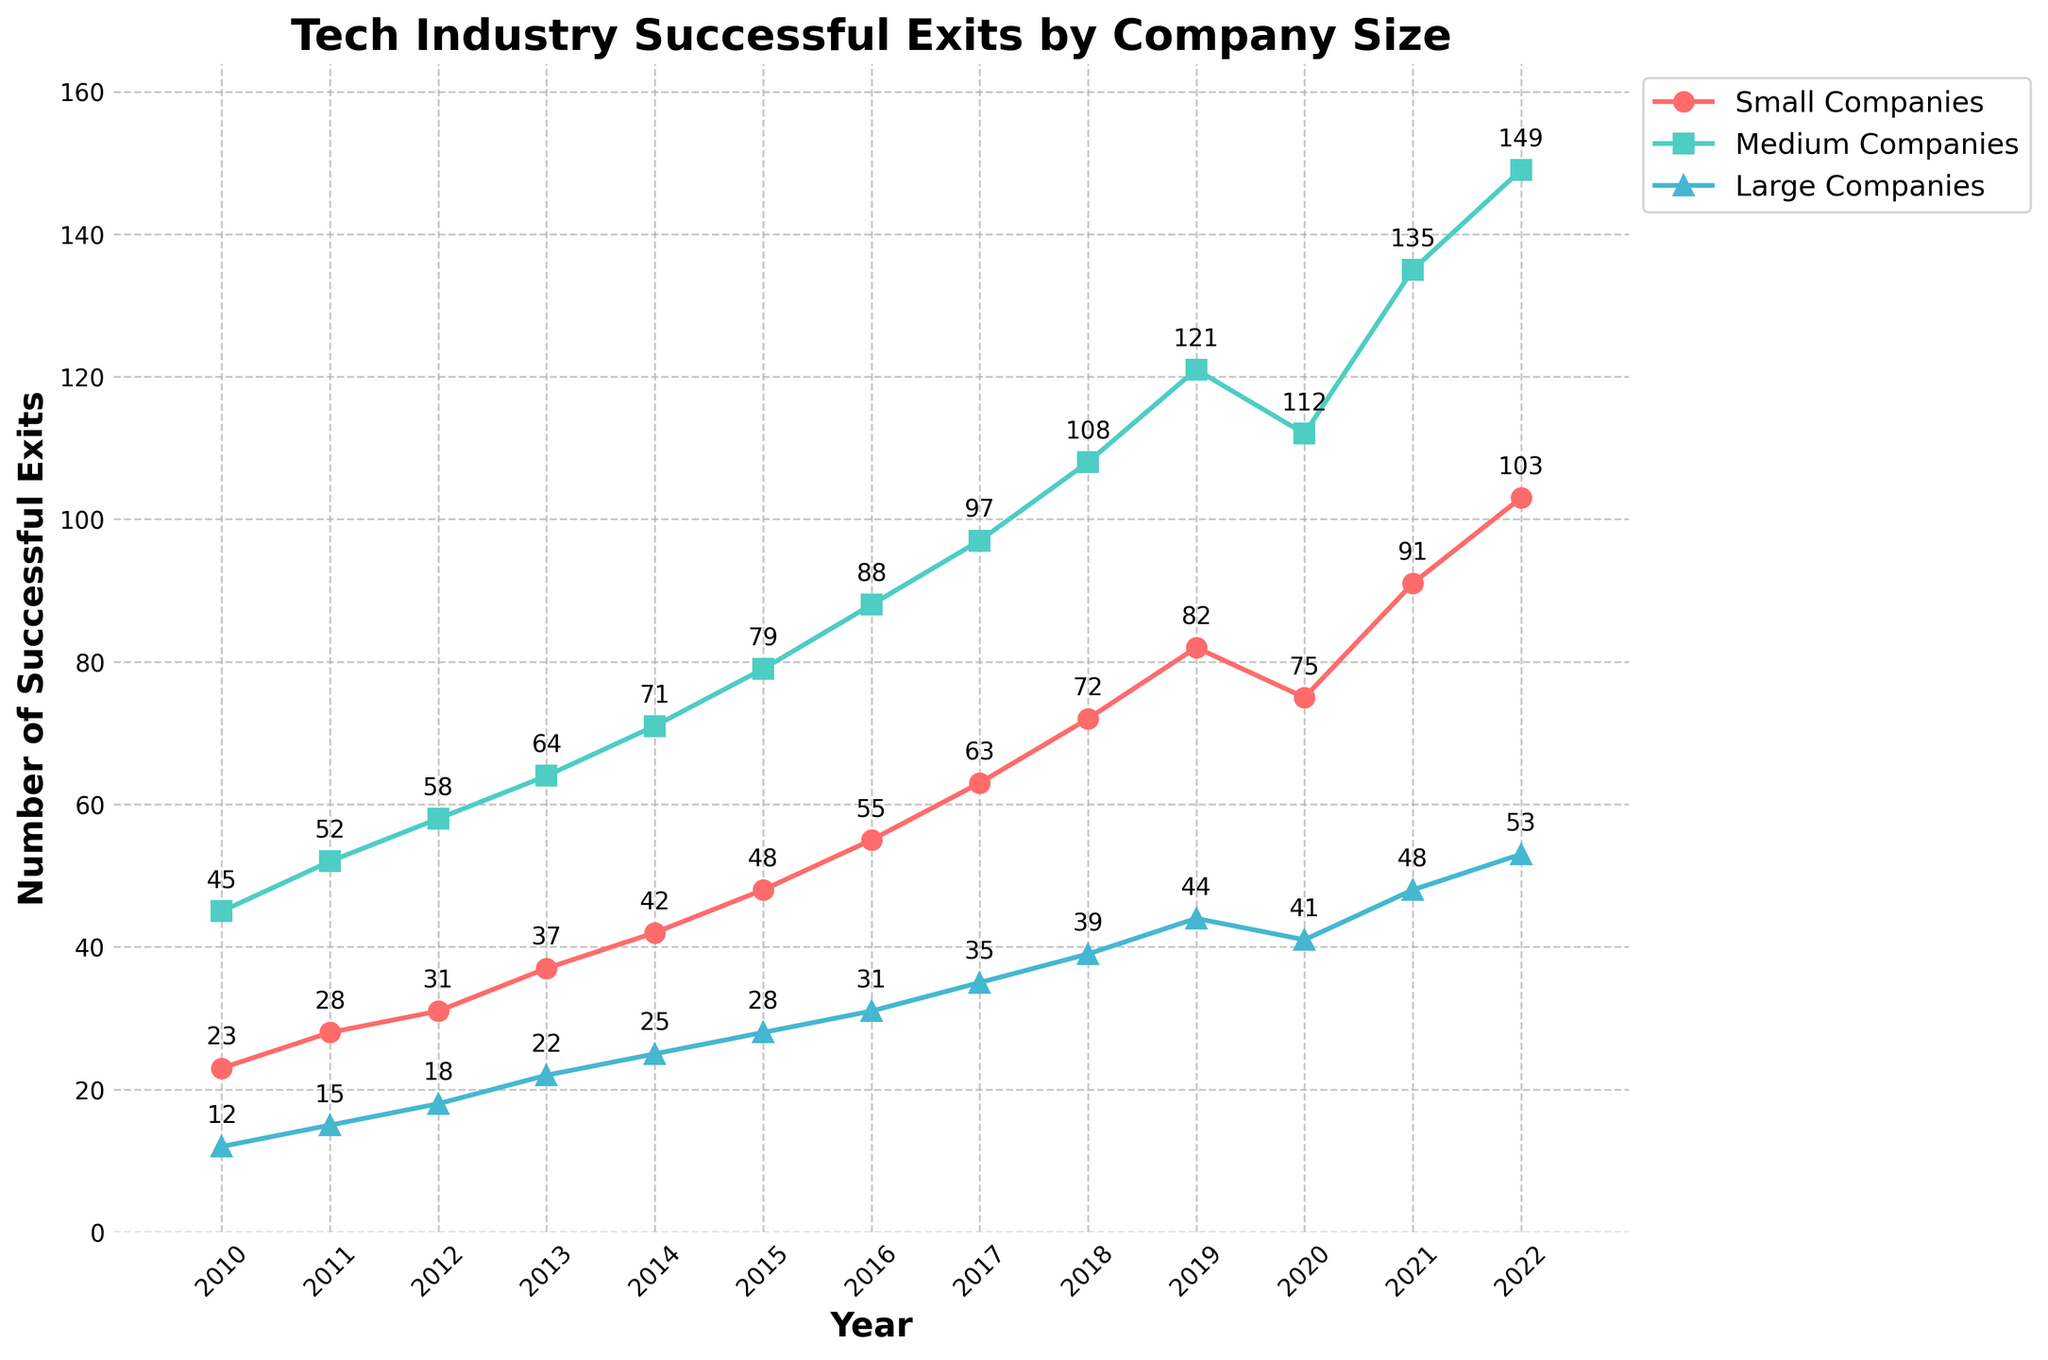What's the trend of successful exits for small companies from 2010 to 2022? The plot line for small companies shows a consistent increase in the number of successful exits from 2010 (23) to 2022 (103). Each year, the number of successful exits grows, indicating an upward trend.
Answer: Consistent increase Which year had the highest number of successful exits for medium companies, and what is the number? By following the green plot line for medium companies, the peak is visible in 2022, with the number indicated near the line as 149.
Answer: 2022, 149 How many successful exits did large companies have in 2015 and 2020, and what is their difference? From the blue plot line, the number of successful exits for large companies is labeled as 28 in 2015 and 41 in 2020. The difference is calculated as 41 - 28 = 13.
Answer: 13 In which year did small companies first surpass 50 successful exits? The red plot line for small companies first reaches above 50 successful exits in 2016, with the point labeled as 55.
Answer: 2016 Compare the growth in successful exits from 2010 to 2020 for medium companies and large companies. For medium companies, the number of successful exits grows from 45 in 2010 to 112 in 2020, with a total increase of 112 - 45 = 67. For large companies, the increase is from 12 in 2010 to 41 in 2020, giving 41 - 12 = 29. Thus, medium companies had a larger growth.
Answer: Medium companies: 67, Large companies: 29 Which category had the least number of successful exits in 2018? In 2018, the plot shows that small companies have 72, medium companies have 108, and large companies have 39 successful exits. The smallest number is for large companies at 39.
Answer: Large companies Calculate the average number of successful exits for small companies between 2010 and 2015. The numbers for small companies from 2010 to 2015 are 23, 28, 31, 37, 42, and 48. Adding these gives 23 + 28 + 31 + 37 + 42 + 48 = 209. Dividing by 6 years, 209 / 6 ≈ 34.83.
Answer: 34.83 How did the number of successful exits for large companies change from 2019 to 2020? From the plot, the number of successful exits for large companies in 2019 is 44 and in 2020 is 41. The change is a decrease of 44 - 41 = 3.
Answer: Decrease by 3 What is the total number of successful exits across all company sizes in 2021? From the plot, small companies had 91, medium companies had 135, and large companies had 48 successful exits in 2021. Adding these gives 91 + 135 + 48 = 274.
Answer: 274 In which year did medium companies have exactly double the number of exits compared to large companies? Reviewing the data, in 2014 medium companies had 71 exits while large companies had 25. Dividing 71 by 25 gives 71 / 25 = 2.84. The closest year with the exact double is not specified directly in the plot, so further inspection is required.
Answer: Not directly on the plot 